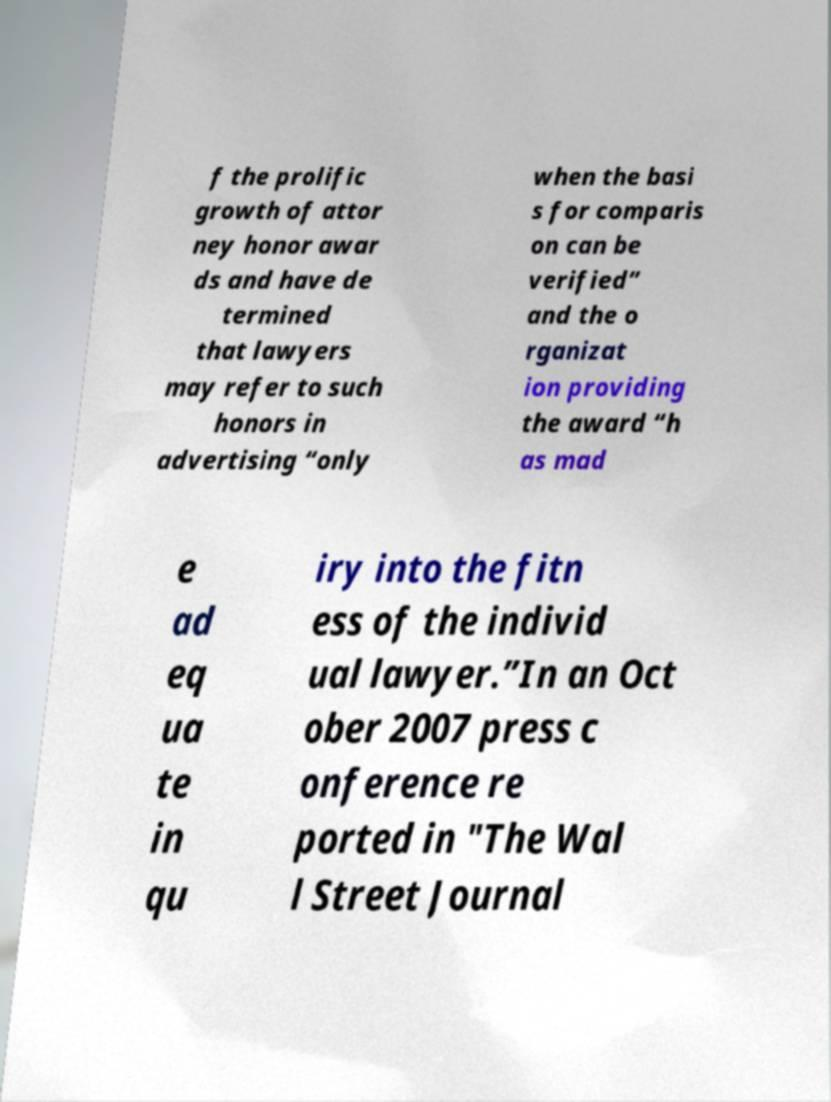Can you accurately transcribe the text from the provided image for me? f the prolific growth of attor ney honor awar ds and have de termined that lawyers may refer to such honors in advertising “only when the basi s for comparis on can be verified” and the o rganizat ion providing the award “h as mad e ad eq ua te in qu iry into the fitn ess of the individ ual lawyer.”In an Oct ober 2007 press c onference re ported in "The Wal l Street Journal 